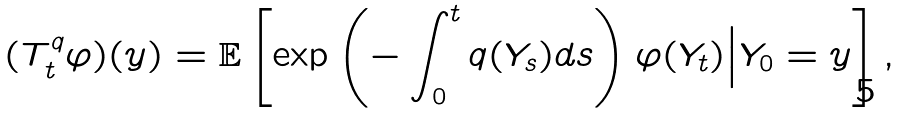Convert formula to latex. <formula><loc_0><loc_0><loc_500><loc_500>( T _ { t } ^ { q } \varphi ) ( y ) = \mathbb { E } \left [ \exp \left ( - \int _ { 0 } ^ { t } q ( Y _ { s } ) d s \right ) \varphi ( Y _ { t } ) \Big | Y _ { 0 } = y \right ] ,</formula> 